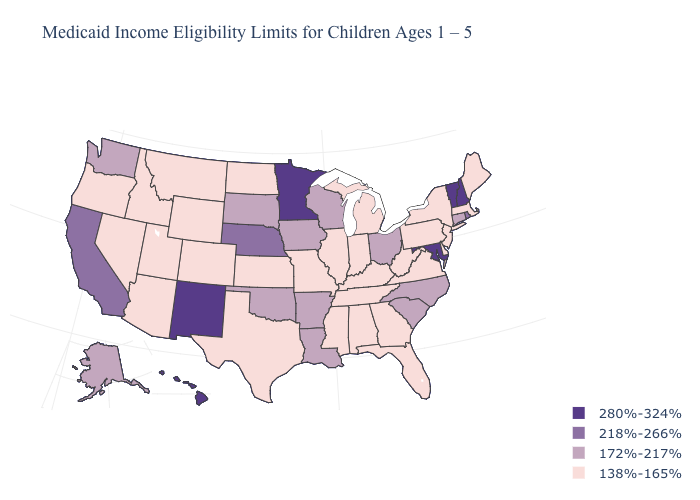What is the lowest value in states that border New Jersey?
Quick response, please. 138%-165%. Name the states that have a value in the range 172%-217%?
Be succinct. Alaska, Arkansas, Connecticut, Iowa, Louisiana, North Carolina, Ohio, Oklahoma, South Carolina, South Dakota, Washington, Wisconsin. Does New Jersey have the highest value in the Northeast?
Concise answer only. No. What is the value of Nebraska?
Keep it brief. 218%-266%. Among the states that border New Hampshire , which have the lowest value?
Quick response, please. Maine, Massachusetts. Does Oklahoma have the same value as Iowa?
Concise answer only. Yes. Does Indiana have the highest value in the USA?
Answer briefly. No. Name the states that have a value in the range 138%-165%?
Short answer required. Alabama, Arizona, Colorado, Delaware, Florida, Georgia, Idaho, Illinois, Indiana, Kansas, Kentucky, Maine, Massachusetts, Michigan, Mississippi, Missouri, Montana, Nevada, New Jersey, New York, North Dakota, Oregon, Pennsylvania, Tennessee, Texas, Utah, Virginia, West Virginia, Wyoming. What is the value of Arizona?
Be succinct. 138%-165%. Does the first symbol in the legend represent the smallest category?
Concise answer only. No. Name the states that have a value in the range 280%-324%?
Answer briefly. Hawaii, Maryland, Minnesota, New Hampshire, New Mexico, Vermont. Which states have the highest value in the USA?
Quick response, please. Hawaii, Maryland, Minnesota, New Hampshire, New Mexico, Vermont. What is the value of Washington?
Concise answer only. 172%-217%. Name the states that have a value in the range 218%-266%?
Concise answer only. California, Nebraska, Rhode Island. What is the value of Vermont?
Concise answer only. 280%-324%. 